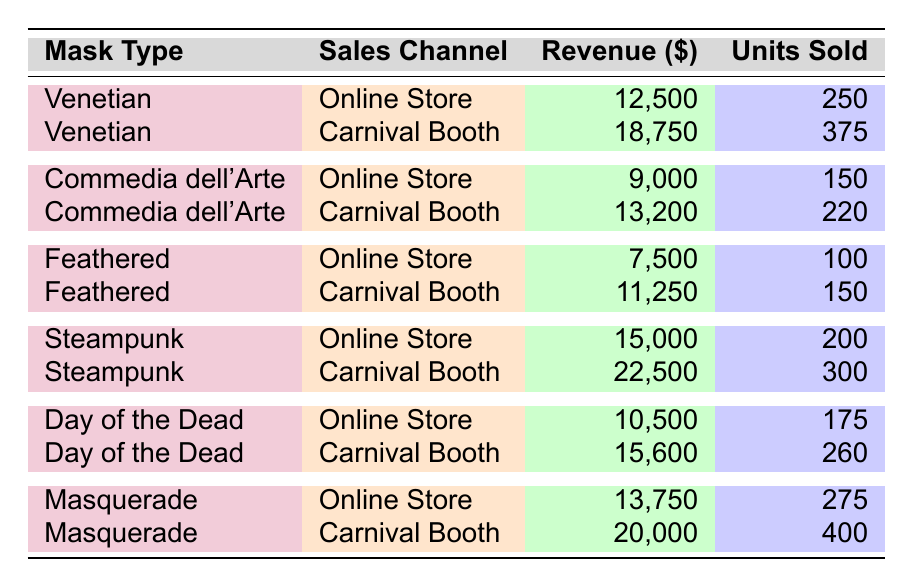What is the total revenue generated from the sales of Venetian masks? The revenue from Venetian masks includes $12,500 from the Online Store and $18,750 from the Carnival Booth. Adding these together gives $12,500 + $18,750 = $31,250.
Answer: $31,250 How many units of Feathered masks were sold at the Carnival Booth? The table shows that 150 units of Feathered masks were sold at the Carnival Booth, as directly stated in the data.
Answer: 150 Which mask type had the highest revenue from the Online Store? By comparing the revenues from the Online Store, Venetian ($12,500), Commedia dell'Arte ($9,000), Feathered ($7,500), Steampunk ($15,000), Day of the Dead ($10,500), and Masquerade ($13,750), Steampunk has the highest revenue of $15,000.
Answer: Steampunk What is the combined revenue from all mask types sold through the Carnival Booth? To find the combined revenue from the Carnival Booth, add the revenues: Venetian ($18,750), Commedia dell'Arte ($13,200), Feathered ($11,250), Steampunk ($22,500), Day of the Dead ($15,600), and Masquerade ($20,000). The total is calculated as $18,750 + $13,200 + $11,250 + $22,500 + $15,600 + $20,000 = $101,300.
Answer: $101,300 Are there more units sold of Masquerade masks at the Carnival Booth than the Online Store? The units sold for Masquerade masks at the Carnival Booth is 400, while at the Online Store it is 275. Since 400 is greater than 275, the statement is true.
Answer: Yes What is the average revenue per unit sold for the Steampunk masks? The revenue for Steampunk masks is $15,000 (Online Store) + $22,500 (Carnival Booth) = $37,500, and the total units sold is 200 (Online Store) + 300 (Carnival Booth) = 500. Therefore, the average revenue per unit is calculated as $37,500 / 500 = $75.
Answer: $75 Which sales channel generated the highest total revenue? To determine the sales channel with the highest revenue, sum the revenues for both channels: Online Store ($12,500 + 9,000 + 7,500 + 15,000 + 10,500 + 13,750 = $68,250) and Carnival Booth ($18,750 + 13,200 + 11,250 + 22,500 + 15,600 + 20,000 = $101,300). The Carnival Booth has the higher total.
Answer: Carnival Booth How does the revenue from Commedia dell'Arte masks compare between the two sales channels? The revenue from Commedia dell'Arte in the Online Store is $9,000 and in the Carnival Booth is $13,200. Comparing these reveals that $13,200 is greater than $9,000, indicating a better performance in the Carnival Booth.
Answer: $13,200 > $9,000 Calculate the difference in total units sold between the Day of the Dead masks and the Feathered masks. For Day of the Dead, units sold are 175 (Online Store) + 260 (Carnival Booth) = 435. For Feathered masks, units sold are 100 (Online Store) + 150 (Carnival Booth) = 250. The difference is calculated as 435 - 250 = 185.
Answer: 185 Did any mask type generate more revenue through the Carnival Booth than via the Online Store? By checking each mask type, it appears that all mask types (Venetian, Commedia dell'Arte, Feathered, Steampunk, Day of the Dead, Masquerade) generated more revenue in the Carnival Booth compared to the Online Store. Thus, the statement is true.
Answer: Yes 